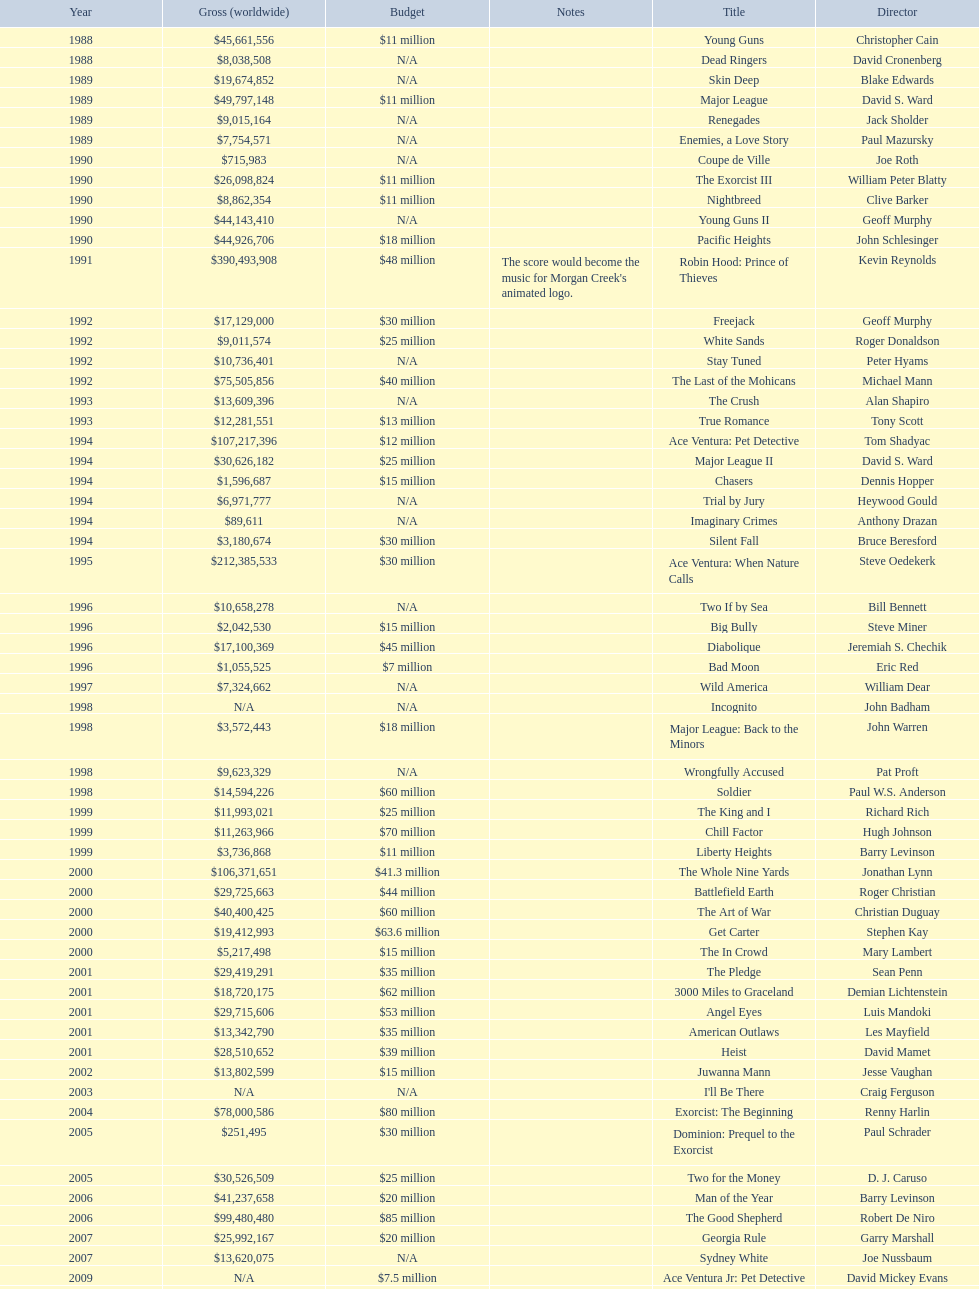What movie came out after bad moon? Wild America. 